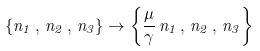Convert formula to latex. <formula><loc_0><loc_0><loc_500><loc_500>\left \{ n _ { 1 } \, , \, n _ { 2 } \, , \, n _ { 3 } \right \} \rightarrow \left \{ \frac { \mu } { \gamma } \, n _ { 1 } \, , \, n _ { 2 } \, , \, n _ { 3 } \right \}</formula> 